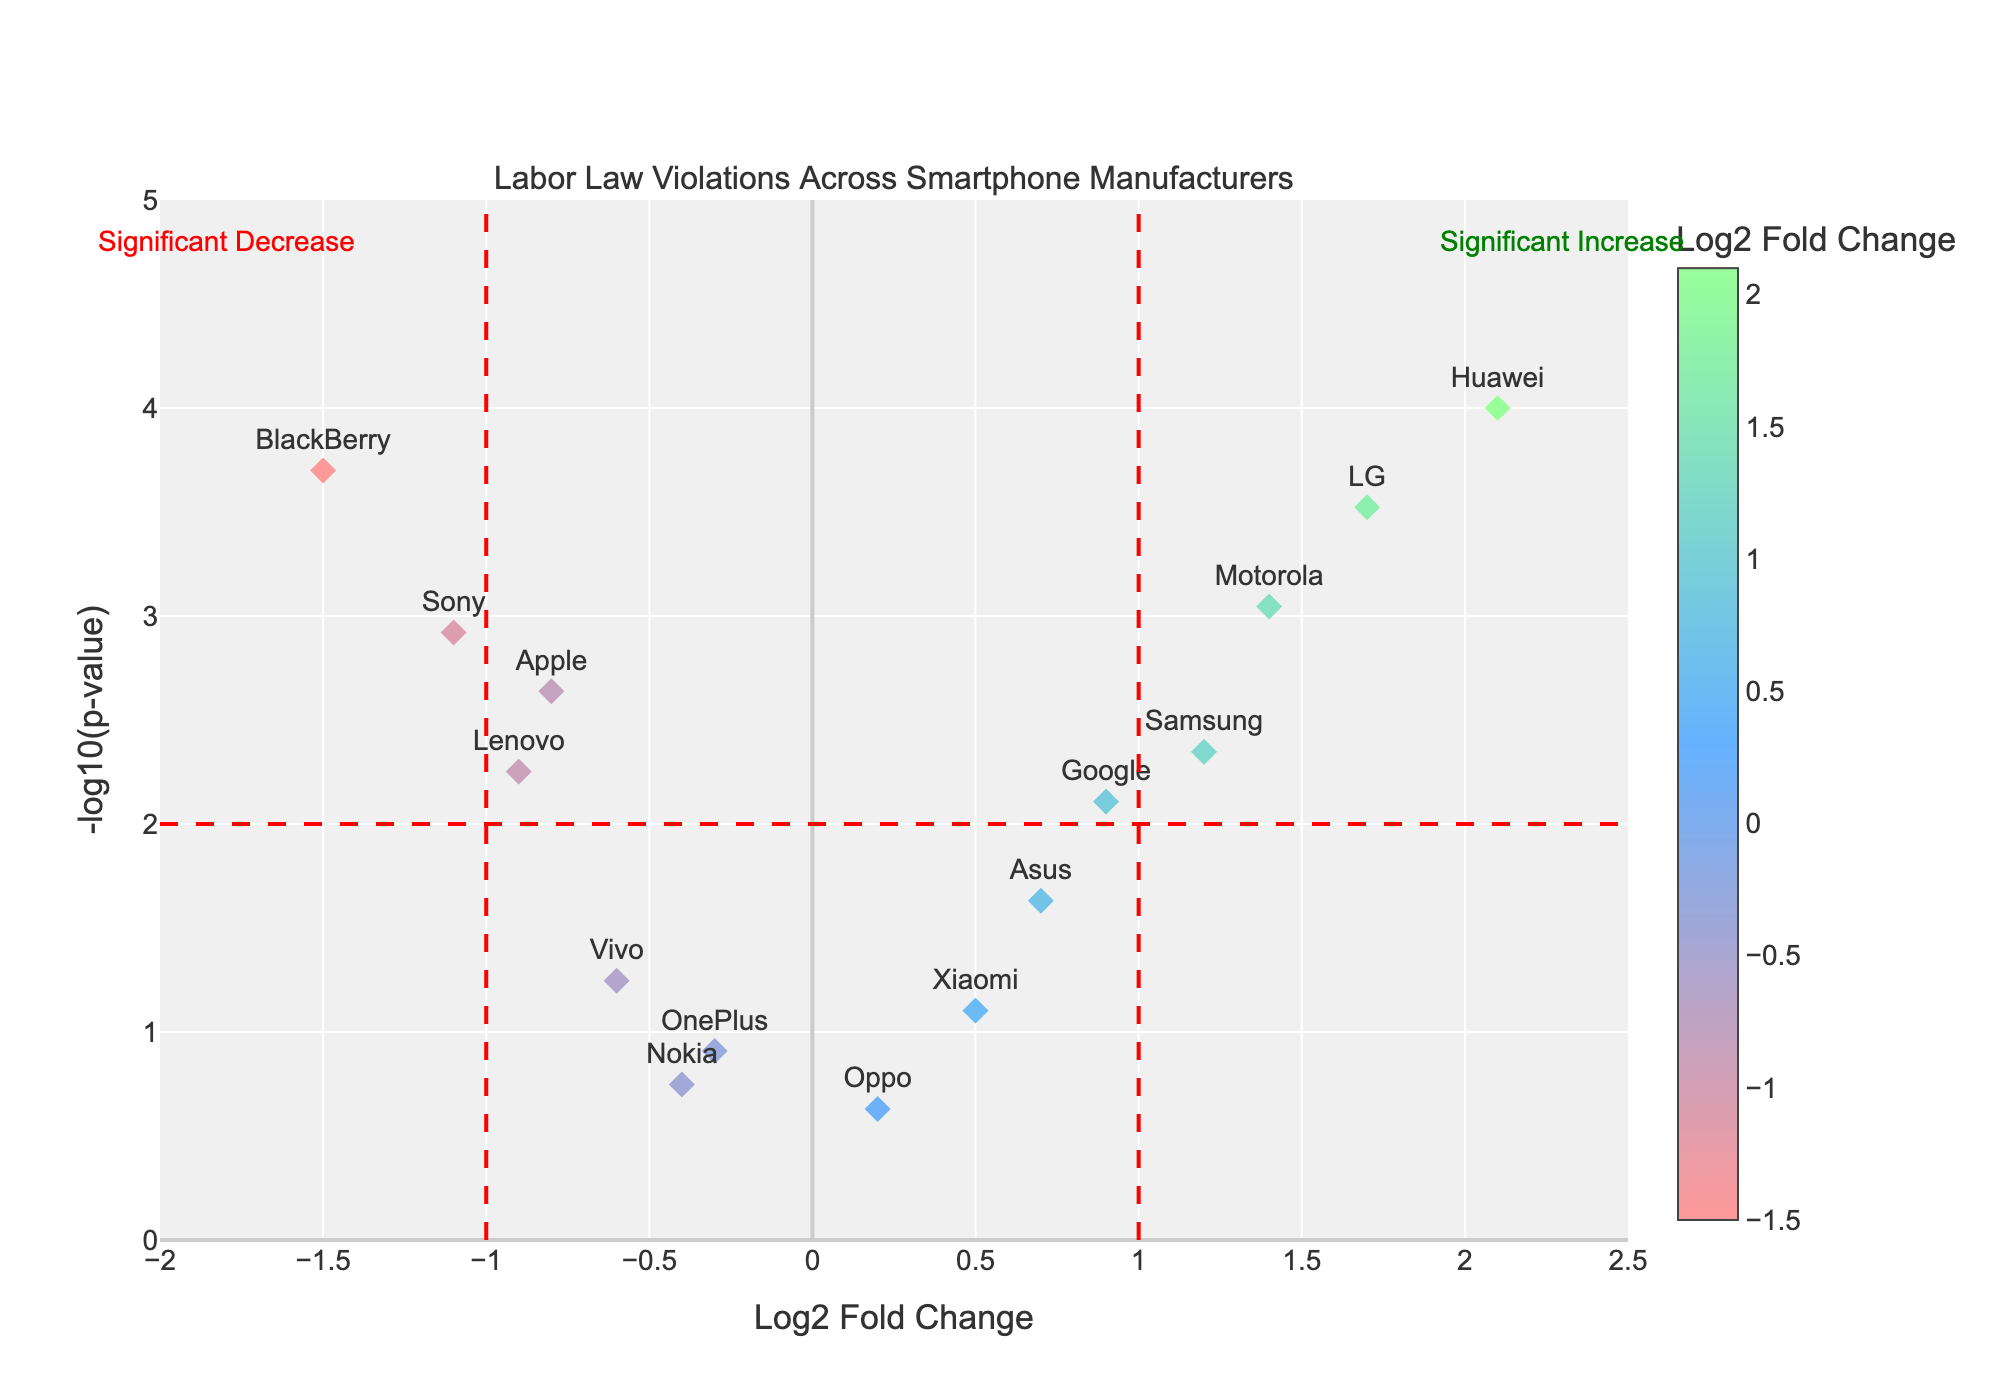What does the title of the plot indicate? The title "Labor Law Violations Across Smartphone Manufacturers" provides an overview that the plot is comparing major smartphone manufacturers based on their labor law violations.
Answer: The plot compares labor law violations across smartphone manufacturers How is the color of the markers determined? The color of the markers is determined by the Log2 Fold Change values, with a custom color scale defined from red to blue to green, representing negative to positive values respectively.
Answer: Color corresponds to Log2 Fold Change values Which company has the highest -log10(p-value)? To determine this, look for the marker placed at the maximum value on the y-axis. The highest -log10(p-value) corresponds to Huawei.
Answer: Huawei How many companies exhibit a Log2 Fold Change greater than 1? From the plot, Samsung, Huawei, LG, and Motorola have Log2 Fold Changes greater than 1, totaling up to 4 companies.
Answer: 4 companies Which company shows the greatest decrease in labor law violations? The company with the lowest Log2 Fold Change value demonstrates the greatest decrease. BlackBerry, with a Log2 Fold Change of -1.5, shows the greatest decrease.
Answer: BlackBerry How many companies are plotted with P-values less than 0.01? Identify the markers positioned above the -log10(p-value) threshold line at y=2 (representing a P-value of 0.01). This includes Apple, Samsung, Huawei, Sony, LG, Motorola, and BlackBerry, summing up to 7 companies.
Answer: 7 companies Which companies are identified as showing a significant increase in violations? To find the companies, look for markers to the right of the Log2 Fold Change threshold line at x=1 and above the P-value threshold line at y=2. These companies are Huawei, LG, and Motorola.
Answer: Huawei, LG, and Motorola What does the red dashed line at x=1 signify? The red dashed line at x=1 sets a significance threshold for the Log2 Fold Change, indicating companies with a Log2 Fold Change above 1 demonstrate a significant increase in labor violations.
Answer: Significance threshold for increase What is the Log2 Fold Change and P-value for Google? Hovering over the marker for Google reveals its detailed information: Log2 Fold Change 0.9 and a P-value of 0.0078.
Answer: Log2 Fold Change 0.9, P-value 0.0078 Which two companies have Log2 Fold Changes closest to 0, and what are their P-values? The companies position near the center of the x-axis; these are Oppo and Nokia, with Log2 Fold Changes of 0.2 and -0.4 respectively, having P-values of 0.2345 and 0.1789 respectively.
Answer: Oppo (P-value 0.2345) and Nokia (P-value 0.1789) 